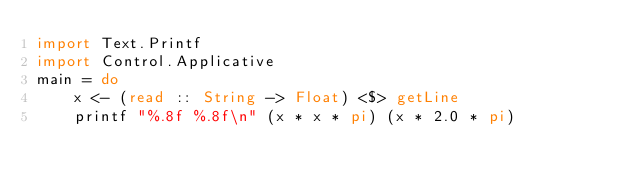<code> <loc_0><loc_0><loc_500><loc_500><_Haskell_>import Text.Printf
import Control.Applicative
main = do
    x <- (read :: String -> Float) <$> getLine
    printf "%.8f %.8f\n" (x * x * pi) (x * 2.0 * pi)</code> 